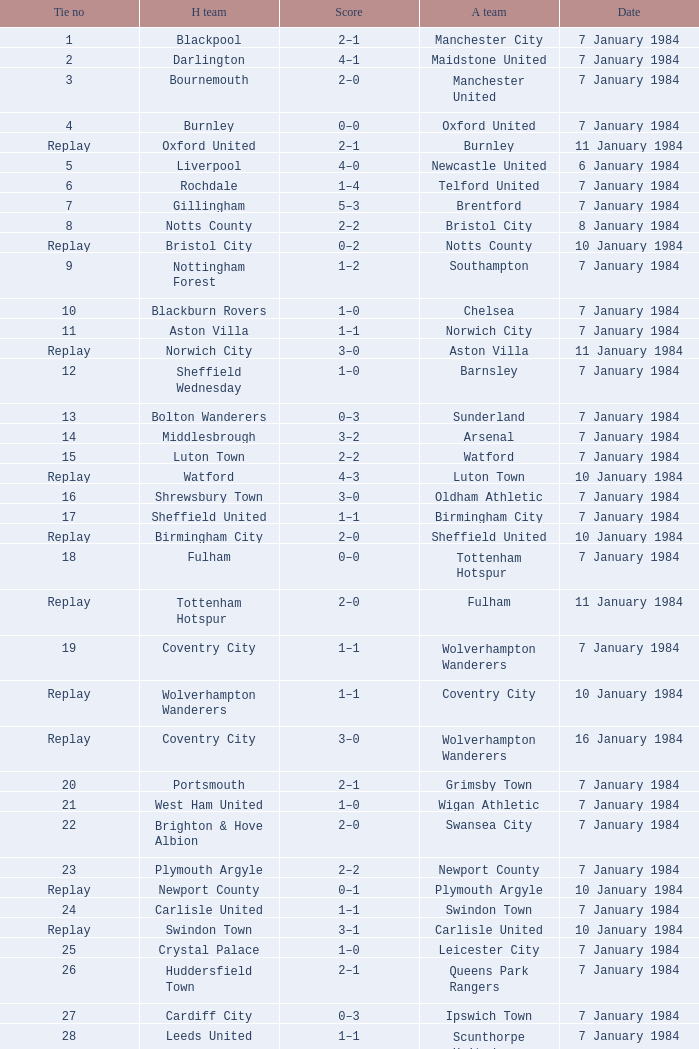Who was the away team against the home team Sheffield United? Birmingham City. 